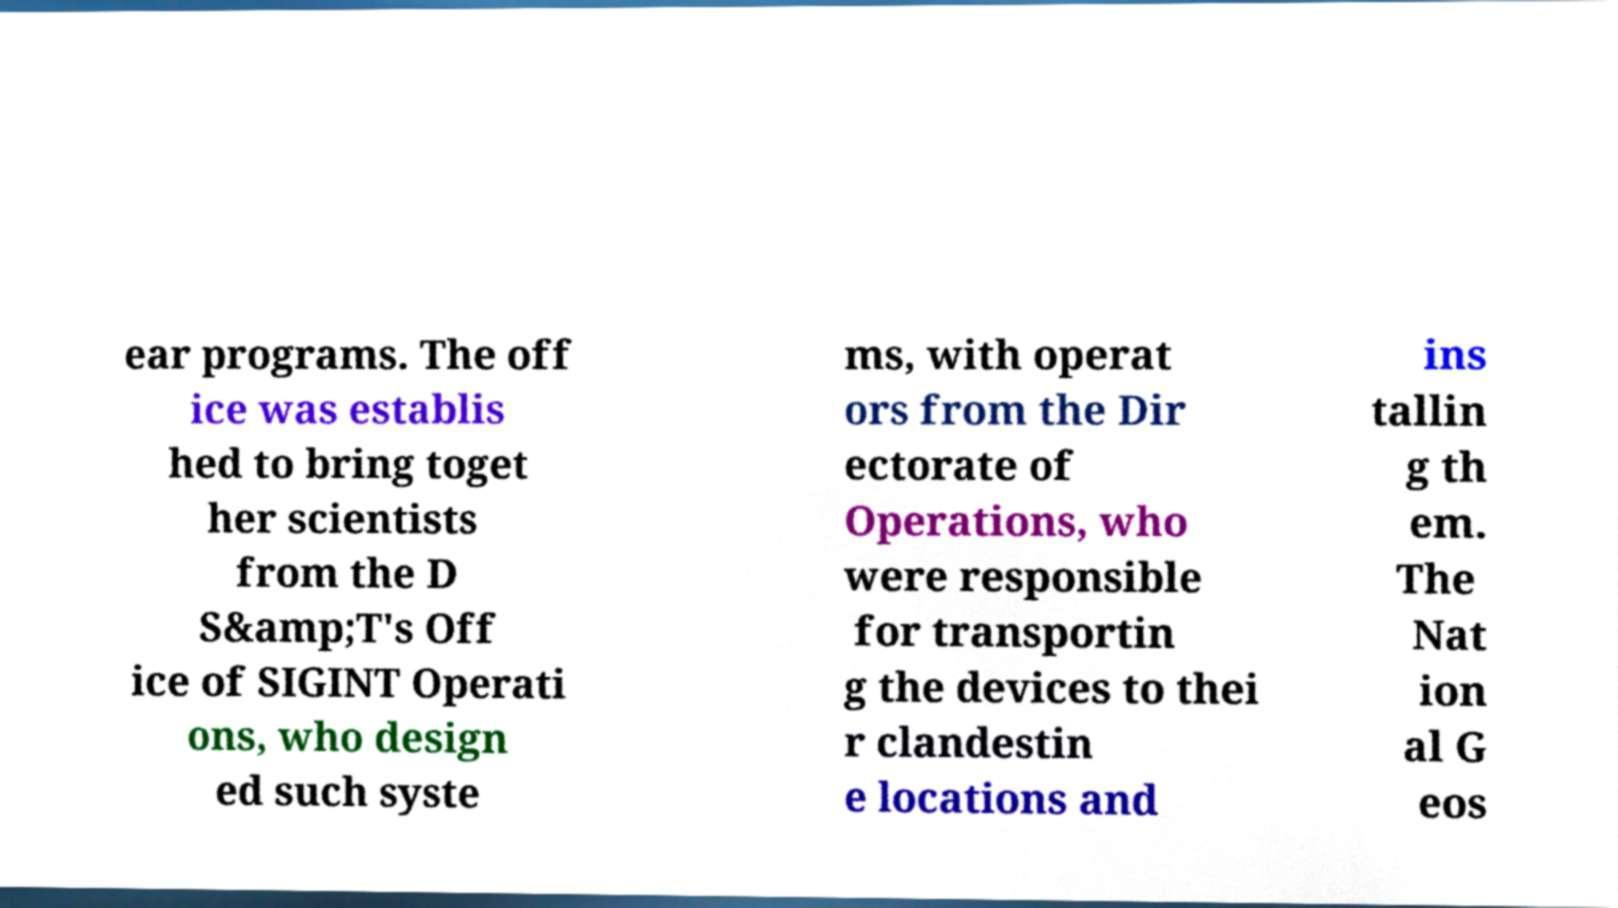Can you read and provide the text displayed in the image?This photo seems to have some interesting text. Can you extract and type it out for me? ear programs. The off ice was establis hed to bring toget her scientists from the D S&amp;T's Off ice of SIGINT Operati ons, who design ed such syste ms, with operat ors from the Dir ectorate of Operations, who were responsible for transportin g the devices to thei r clandestin e locations and ins tallin g th em. The Nat ion al G eos 